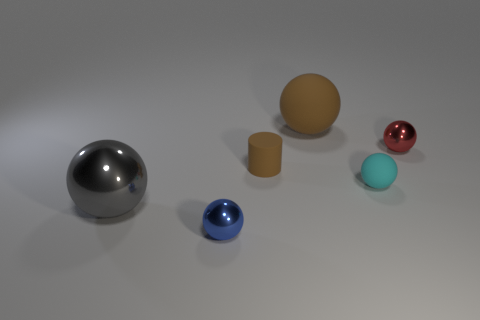Does the ball in front of the gray shiny sphere have the same size as the large metallic object?
Offer a terse response. No. What number of other objects are the same size as the cyan matte sphere?
Offer a terse response. 3. What is the color of the tiny object that is both in front of the rubber cylinder and behind the big shiny sphere?
Your answer should be compact. Cyan. There is a object that is to the right of the tiny cyan object; how big is it?
Your answer should be compact. Small. How many tiny red balls have the same material as the small cyan thing?
Offer a terse response. 0. There is a small matte object that is the same color as the large matte sphere; what shape is it?
Keep it short and to the point. Cylinder. Is the shape of the brown object that is behind the small cylinder the same as  the small brown thing?
Offer a terse response. No. There is another small ball that is the same material as the small red ball; what is its color?
Offer a very short reply. Blue. Are there any blue metallic balls in front of the brown matte thing in front of the large sphere behind the rubber cylinder?
Your answer should be compact. Yes. There is a large gray metal object; what shape is it?
Offer a terse response. Sphere. 